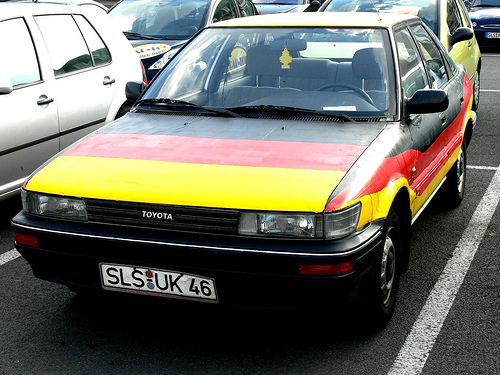<image>
Is there a stripes in the car? Yes. The stripes is contained within or inside the car, showing a containment relationship. 